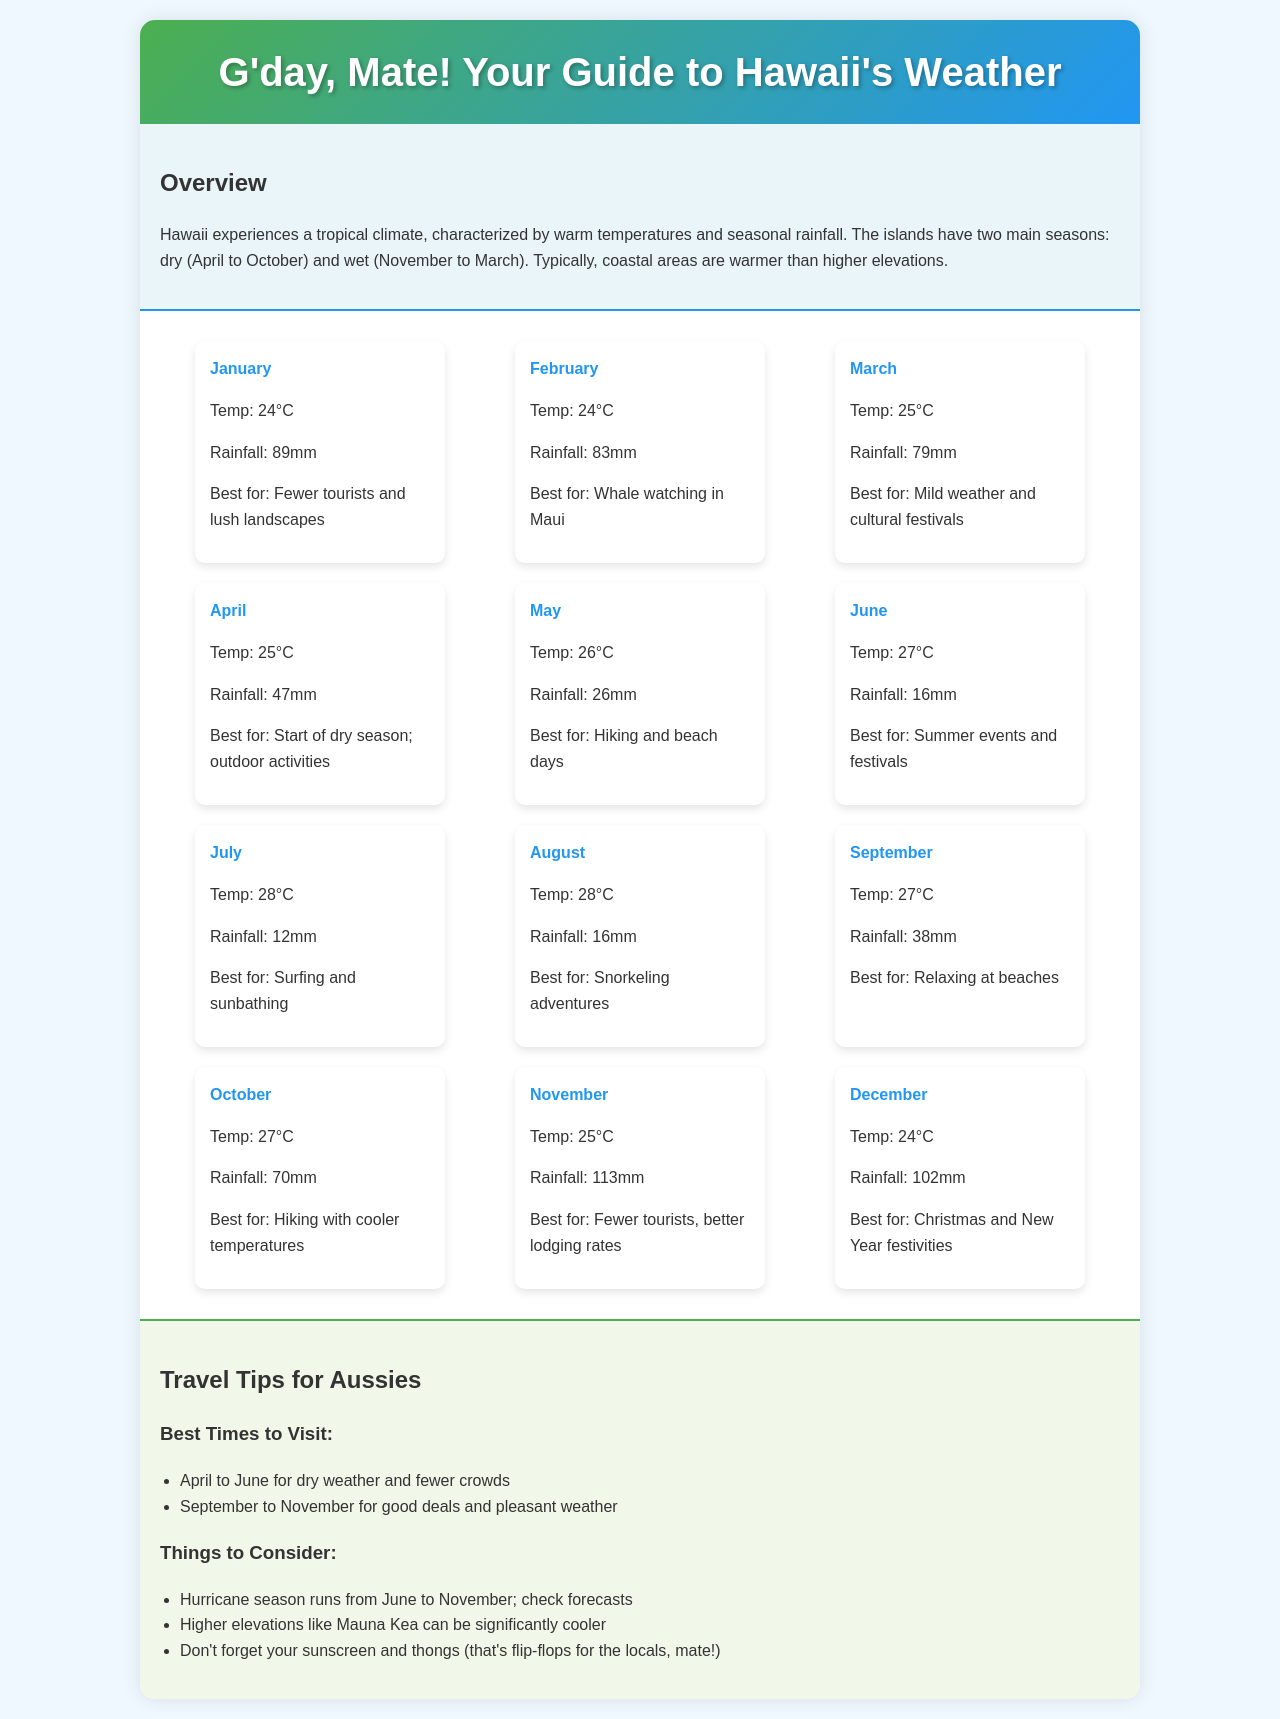What is the temperature in January? The document states that the temperature in January is 24°C.
Answer: 24°C What is the rainfall amount for July? According to the document, July has a rainfall amount of 12mm.
Answer: 12mm What is the best month for whale watching in Maui? The document indicates that February is the best month for whale watching in Maui.
Answer: February Which month marks the start of the dry season? The document mentions that April is when the dry season starts.
Answer: April What travel tip is suggested for visiting in the hurricane season? The document advises checking forecasts during the hurricane season which runs from June to November.
Answer: Check forecasts How many months have an average temperature of 28°C? Analyzing the document, it shows that two months have an average temperature of 28°C: July and August.
Answer: Two months What is the average rainfall in November? The document states that the average rainfall in November is 113mm.
Answer: 113mm Which months are suggested for good deals and pleasant weather? The document lists September to November as the suggested months for good deals and pleasant weather.
Answer: September to November What is the best time for hiking and beach days? According to the document, May is the best month for hiking and beach days.
Answer: May 